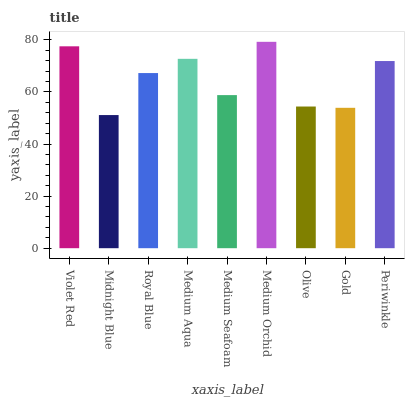Is Midnight Blue the minimum?
Answer yes or no. Yes. Is Medium Orchid the maximum?
Answer yes or no. Yes. Is Royal Blue the minimum?
Answer yes or no. No. Is Royal Blue the maximum?
Answer yes or no. No. Is Royal Blue greater than Midnight Blue?
Answer yes or no. Yes. Is Midnight Blue less than Royal Blue?
Answer yes or no. Yes. Is Midnight Blue greater than Royal Blue?
Answer yes or no. No. Is Royal Blue less than Midnight Blue?
Answer yes or no. No. Is Royal Blue the high median?
Answer yes or no. Yes. Is Royal Blue the low median?
Answer yes or no. Yes. Is Periwinkle the high median?
Answer yes or no. No. Is Midnight Blue the low median?
Answer yes or no. No. 